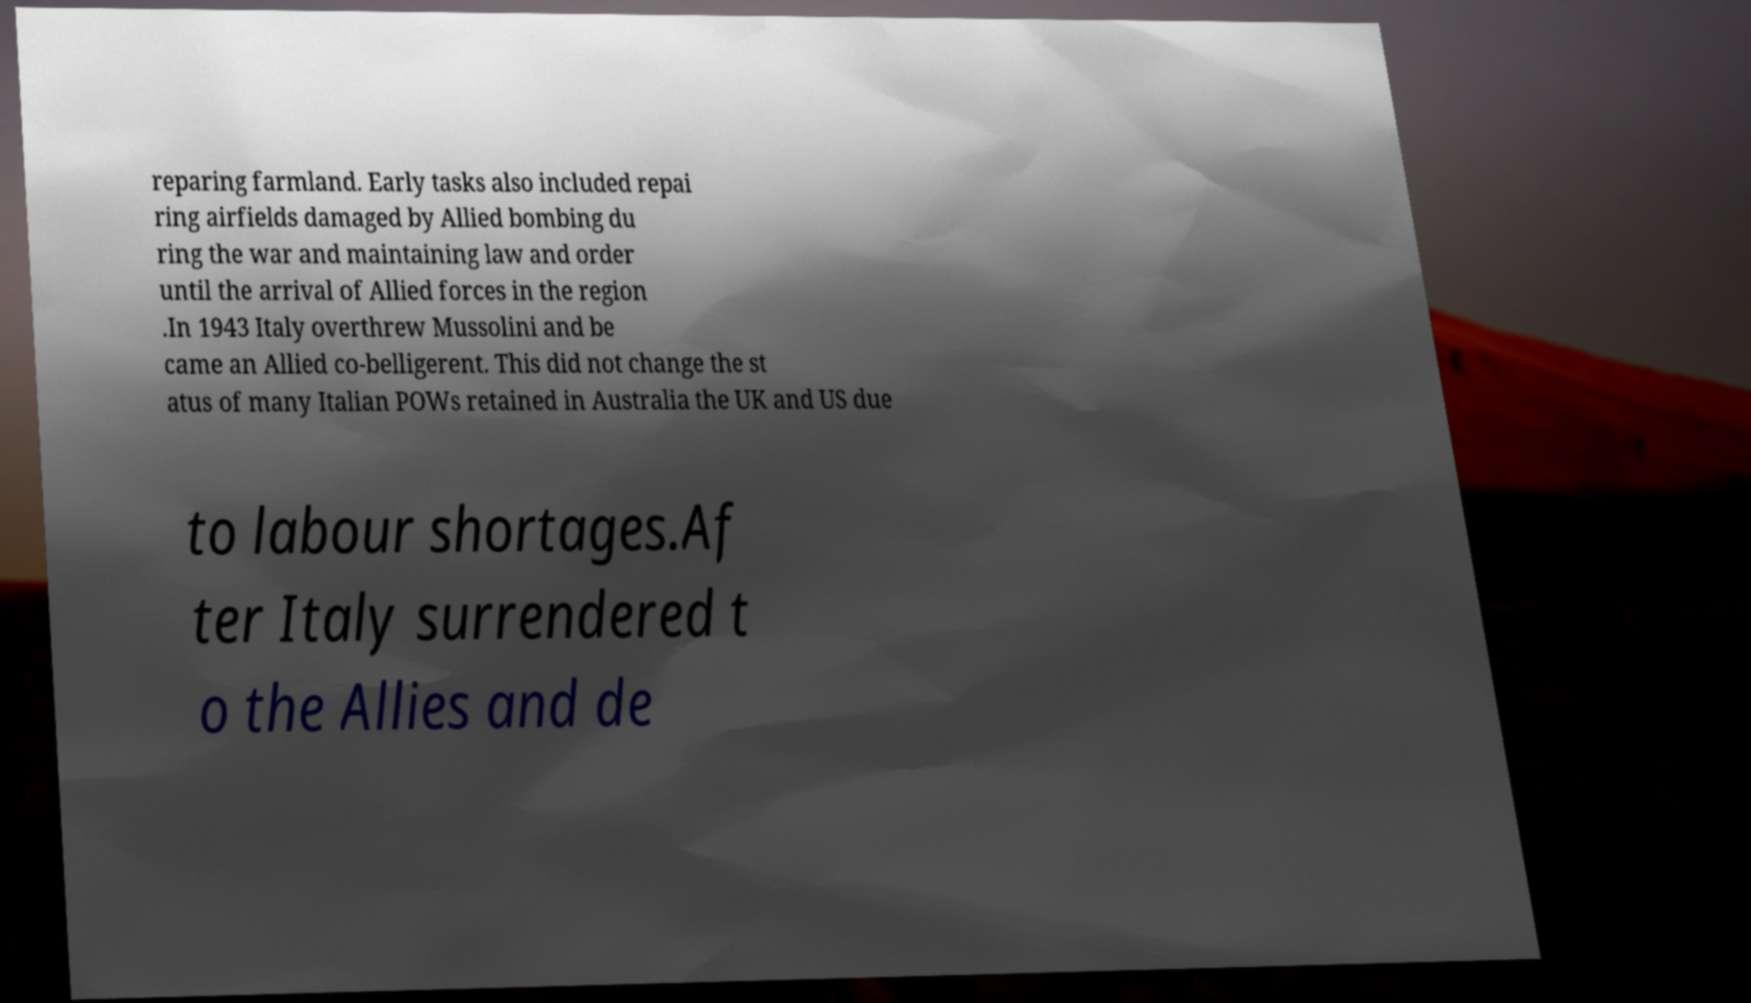Please identify and transcribe the text found in this image. reparing farmland. Early tasks also included repai ring airfields damaged by Allied bombing du ring the war and maintaining law and order until the arrival of Allied forces in the region .In 1943 Italy overthrew Mussolini and be came an Allied co-belligerent. This did not change the st atus of many Italian POWs retained in Australia the UK and US due to labour shortages.Af ter Italy surrendered t o the Allies and de 